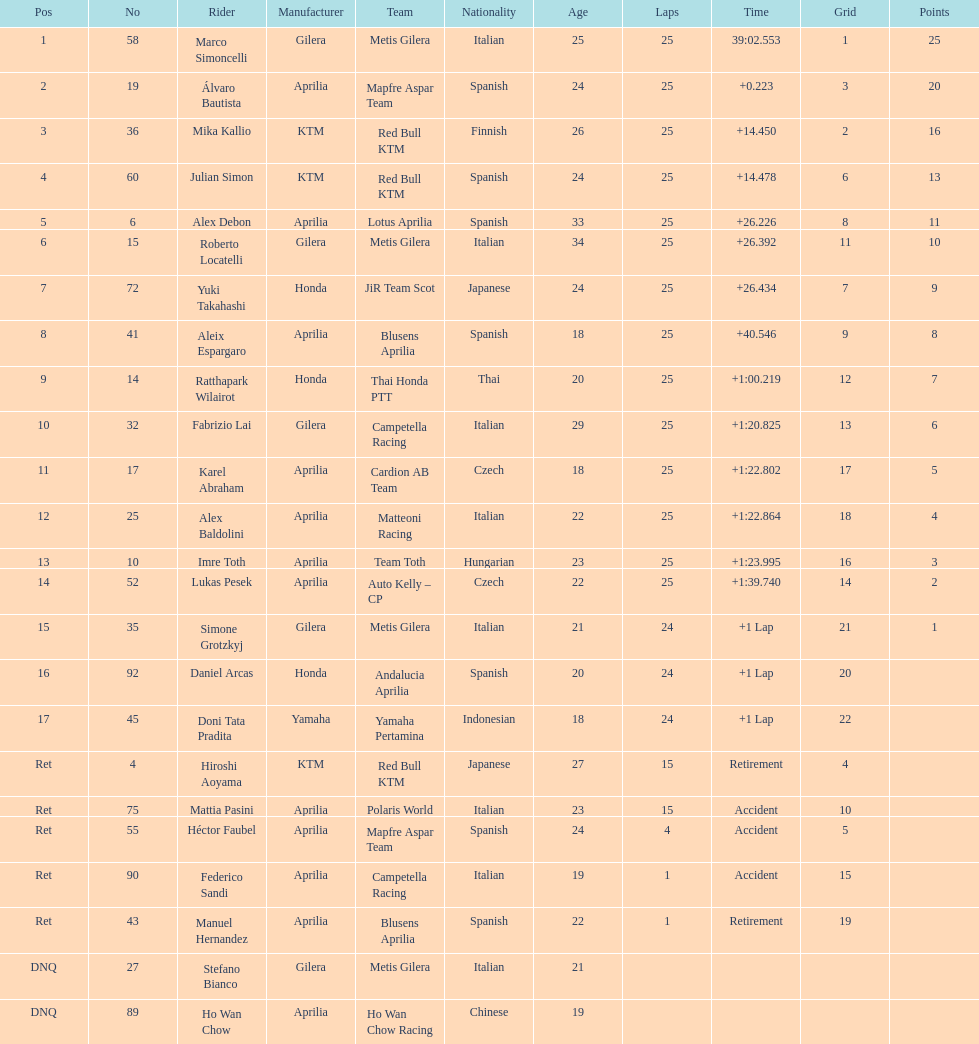The total amount of riders who did not qualify 2. 